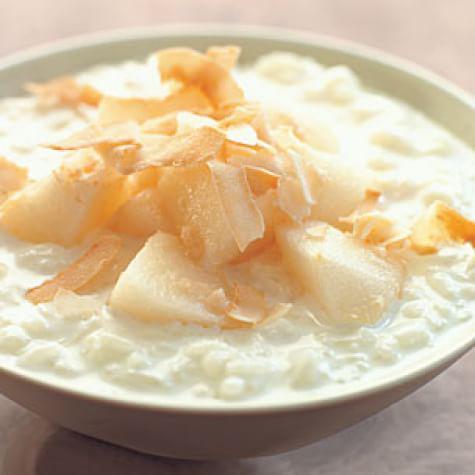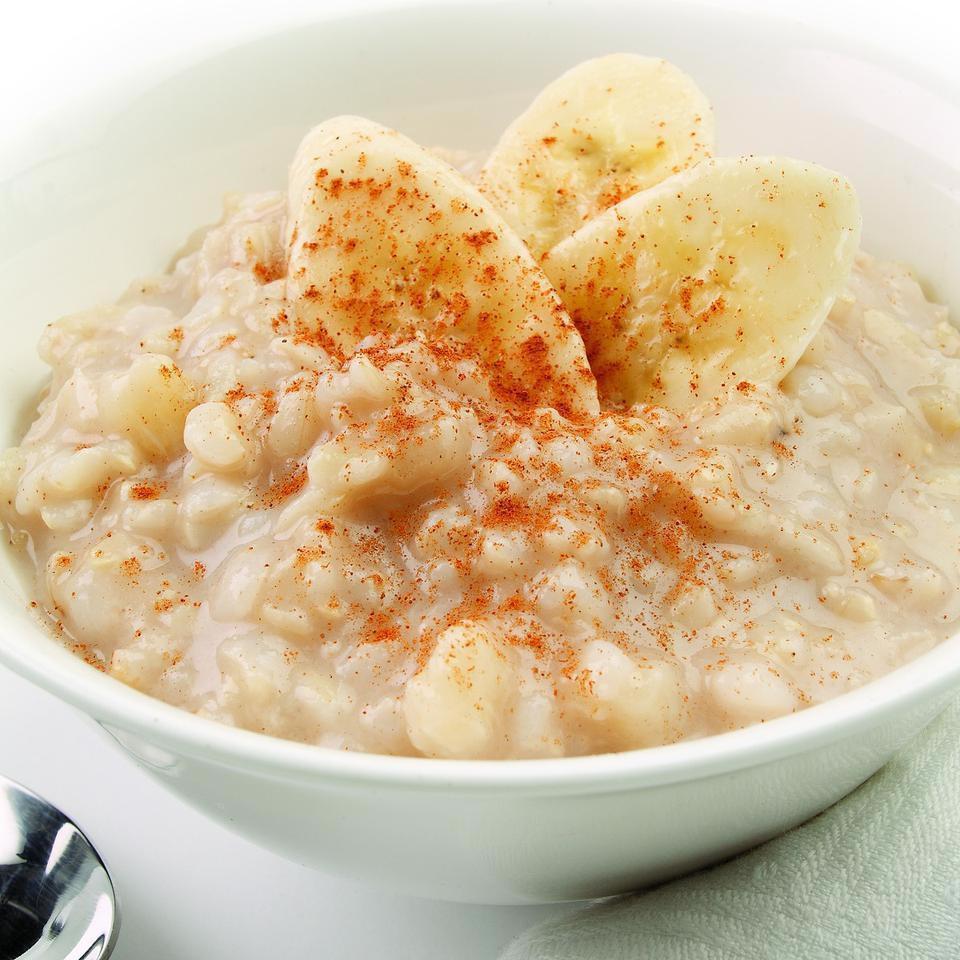The first image is the image on the left, the second image is the image on the right. For the images displayed, is the sentence "All the food items are in bowls." factually correct? Answer yes or no. Yes. The first image is the image on the left, the second image is the image on the right. For the images displayed, is the sentence "An image shows exactly one round bowl that contains something creamy and whitish with brown spice sprinkled on top, and no other ingredients." factually correct? Answer yes or no. No. 